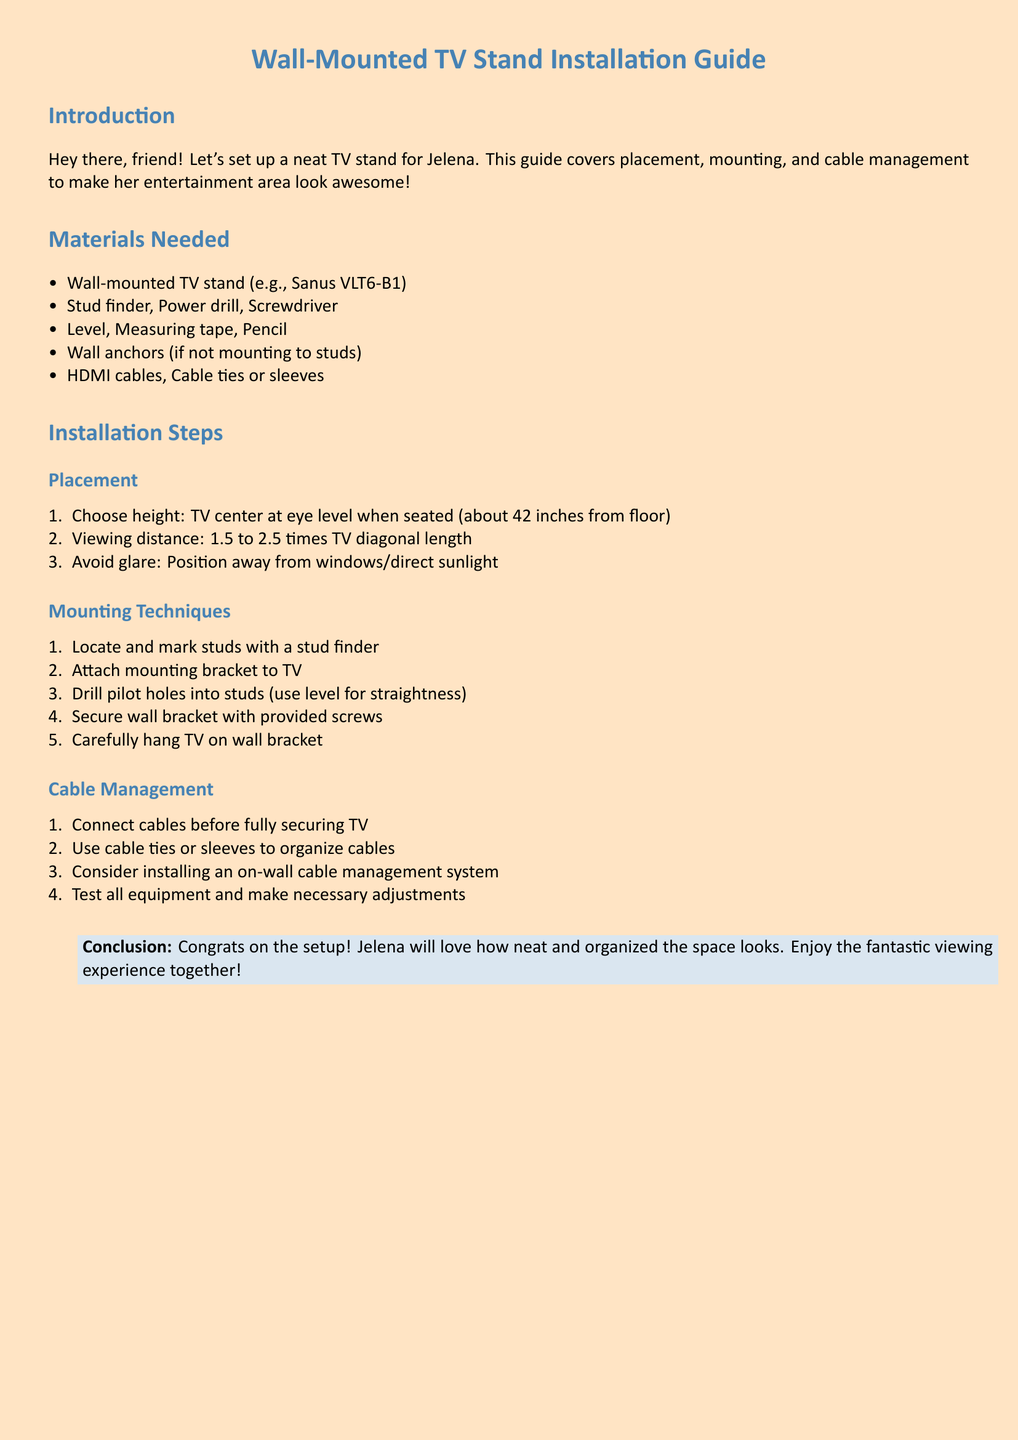what is the recommended height for the TV center? The guide suggests that the TV center should be at eye level when seated, which is about 42 inches from the floor.
Answer: 42 inches which tool is used to locate studs? The document states that a stud finder is required to locate and mark studs.
Answer: stud finder what is the viewing distance range mentioned in the guide? The document specifies that the viewing distance should be 1.5 to 2.5 times the TV diagonal length.
Answer: 1.5 to 2.5 times TV diagonal length how should cables be organized? The guide recommends using cable ties or sleeves to keep the cables organized and tidy.
Answer: cable ties or sleeves what is the first step in the mounting techniques? The first step in the mounting techniques is to locate and mark studs with a stud finder.
Answer: locate and mark studs what is an optional installation consideration for cable management? The document mentions considering the installation of an on-wall cable management system as an optional step.
Answer: on-wall cable management system what is the concluding remark in the guide? The conclusion congratulates the user on the setup and notes that Jelena will love how neat and organized the space looks.
Answer: Congrats on the setup! how should the wall bracket be secured? The guide advises securing the wall bracket with the screws provided in the installation kit.
Answer: with provided screws 